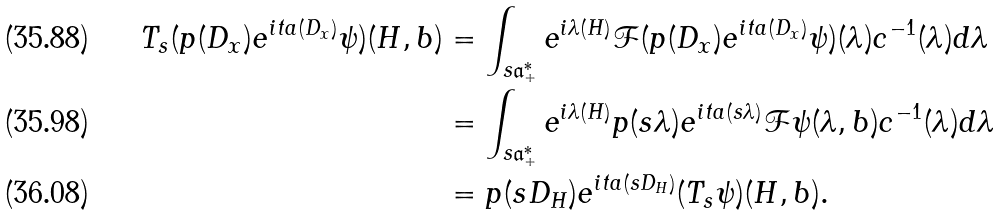Convert formula to latex. <formula><loc_0><loc_0><loc_500><loc_500>T _ { s } ( p ( D _ { x } ) e ^ { i t a ( D _ { x } ) } \psi ) ( H , b ) & = \int _ { s \mathfrak { a } ^ { * } _ { + } } e ^ { i \lambda ( H ) } \mathcal { F } ( p ( D _ { x } ) e ^ { i t a ( D _ { x } ) } \psi ) ( \lambda ) c ^ { - 1 } ( \lambda ) d \lambda \\ & = \int _ { s \mathfrak { a } ^ { * } _ { + } } e ^ { i \lambda ( H ) } p ( s \lambda ) e ^ { i t a ( s \lambda ) } \mathcal { F } \psi ( \lambda , b ) c ^ { - 1 } ( \lambda ) d \lambda \\ & = p ( s D _ { H } ) e ^ { i t a ( s D _ { H } ) } ( T _ { s } \psi ) ( H , b ) .</formula> 